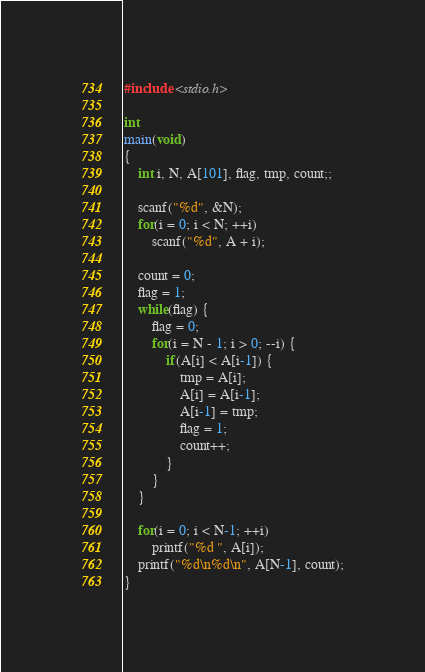<code> <loc_0><loc_0><loc_500><loc_500><_C_>#include <stdio.h>

int
main(void)
{
    int i, N, A[101], flag, tmp, count;;
    
    scanf("%d", &N);
    for(i = 0; i < N; ++i)
        scanf("%d", A + i);
    
    count = 0;
    flag = 1;
    while(flag) {
        flag = 0;
        for(i = N - 1; i > 0; --i) {
            if(A[i] < A[i-1]) {
                tmp = A[i];
                A[i] = A[i-1];
                A[i-1] = tmp;
                flag = 1;
                count++;
            }
        }
    }
    
    for(i = 0; i < N-1; ++i)
        printf("%d ", A[i]);
    printf("%d\n%d\n", A[N-1], count);
}

</code> 